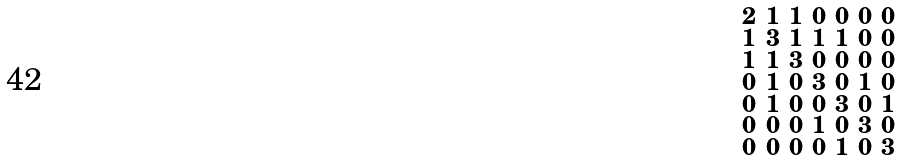Convert formula to latex. <formula><loc_0><loc_0><loc_500><loc_500>\begin{smallmatrix} 2 & 1 & 1 & 0 & 0 & 0 & 0 \\ 1 & 3 & 1 & 1 & 1 & 0 & 0 \\ 1 & 1 & 3 & 0 & 0 & 0 & 0 \\ 0 & 1 & 0 & 3 & 0 & 1 & 0 \\ 0 & 1 & 0 & 0 & 3 & 0 & 1 \\ 0 & 0 & 0 & 1 & 0 & 3 & 0 \\ 0 & 0 & 0 & 0 & 1 & 0 & 3 \end{smallmatrix}</formula> 